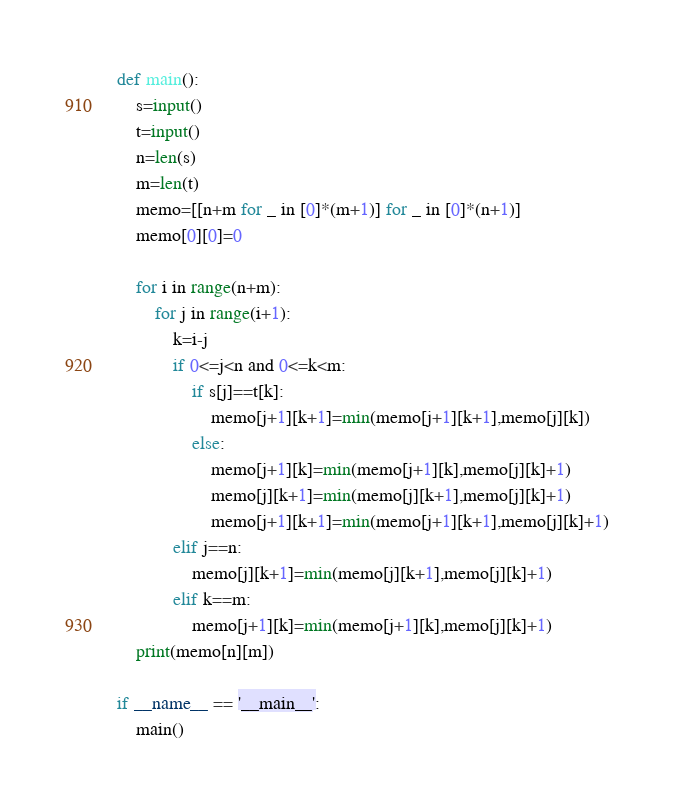<code> <loc_0><loc_0><loc_500><loc_500><_Python_>def main():
    s=input()
    t=input()
    n=len(s)
    m=len(t)
    memo=[[n+m for _ in [0]*(m+1)] for _ in [0]*(n+1)]
    memo[0][0]=0
    
    for i in range(n+m):
        for j in range(i+1):
            k=i-j
            if 0<=j<n and 0<=k<m:
                if s[j]==t[k]:
                    memo[j+1][k+1]=min(memo[j+1][k+1],memo[j][k])
                else:
                    memo[j+1][k]=min(memo[j+1][k],memo[j][k]+1)
                    memo[j][k+1]=min(memo[j][k+1],memo[j][k]+1)
                    memo[j+1][k+1]=min(memo[j+1][k+1],memo[j][k]+1)
            elif j==n:
                memo[j][k+1]=min(memo[j][k+1],memo[j][k]+1)
            elif k==m:
                memo[j+1][k]=min(memo[j+1][k],memo[j][k]+1)
    print(memo[n][m])
                
if __name__ == '__main__':
    main()
</code> 